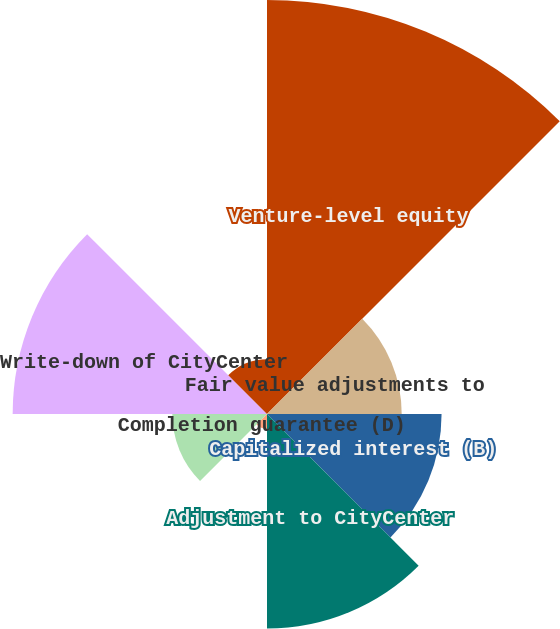Convert chart to OTSL. <chart><loc_0><loc_0><loc_500><loc_500><pie_chart><fcel>Venture-level equity<fcel>Fair value adjustments to<fcel>Capitalized interest (B)<fcel>Adjustment to CityCenter<fcel>Completion guarantee (D)<fcel>Advances to CityCenter net of<fcel>Write-down of CityCenter<fcel>Other adjustments (H)<nl><fcel>30.52%<fcel>9.93%<fcel>12.87%<fcel>15.81%<fcel>1.1%<fcel>6.98%<fcel>18.75%<fcel>4.04%<nl></chart> 